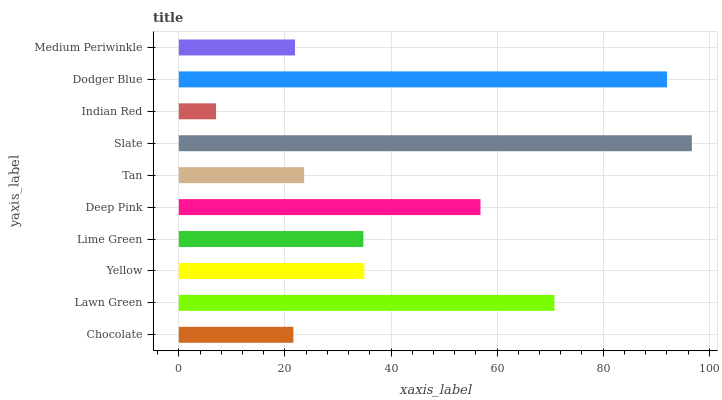Is Indian Red the minimum?
Answer yes or no. Yes. Is Slate the maximum?
Answer yes or no. Yes. Is Lawn Green the minimum?
Answer yes or no. No. Is Lawn Green the maximum?
Answer yes or no. No. Is Lawn Green greater than Chocolate?
Answer yes or no. Yes. Is Chocolate less than Lawn Green?
Answer yes or no. Yes. Is Chocolate greater than Lawn Green?
Answer yes or no. No. Is Lawn Green less than Chocolate?
Answer yes or no. No. Is Yellow the high median?
Answer yes or no. Yes. Is Lime Green the low median?
Answer yes or no. Yes. Is Dodger Blue the high median?
Answer yes or no. No. Is Indian Red the low median?
Answer yes or no. No. 